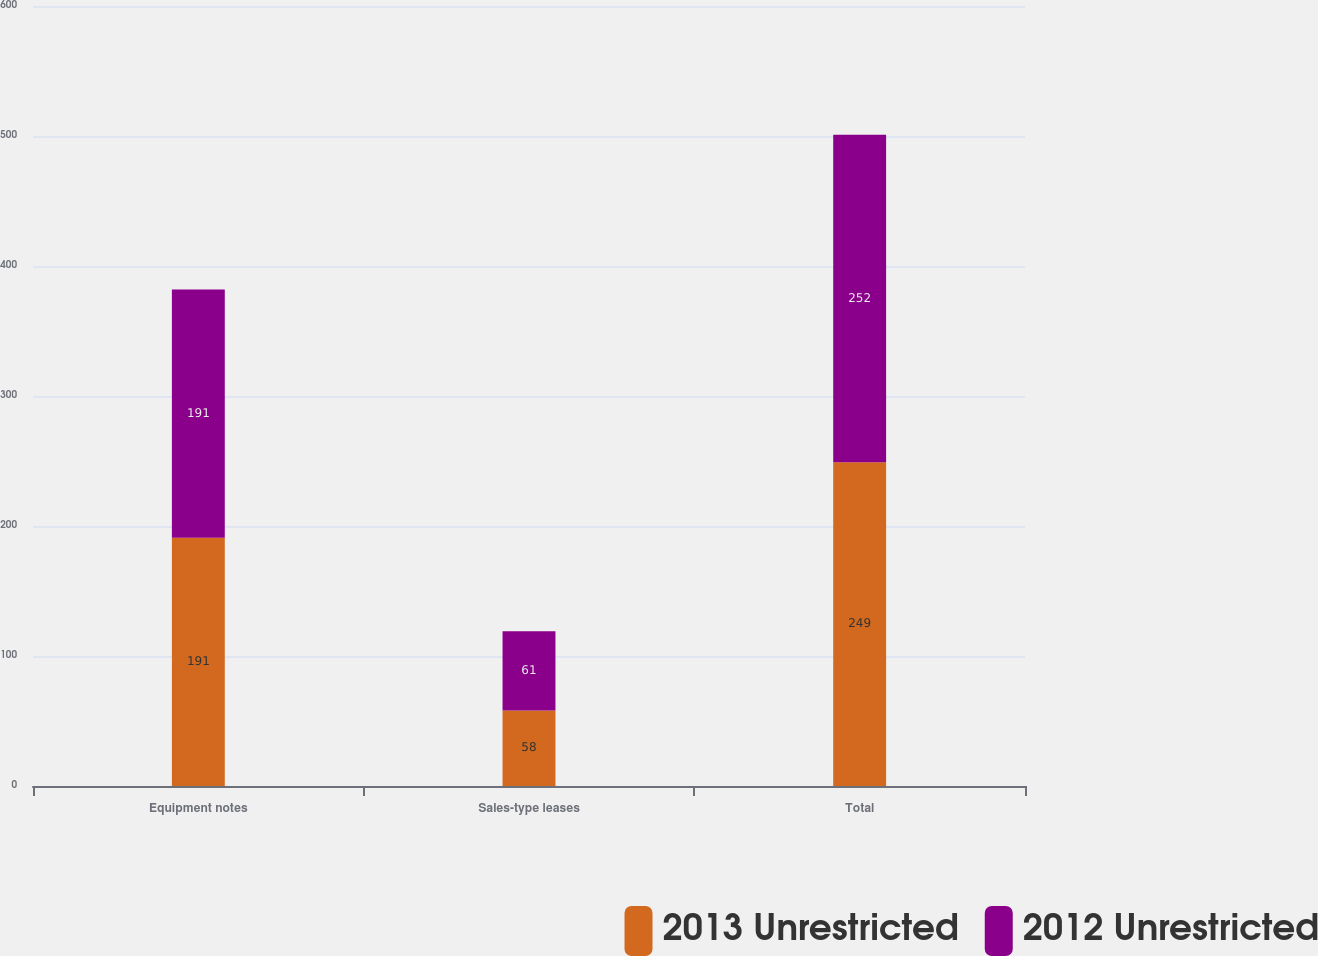<chart> <loc_0><loc_0><loc_500><loc_500><stacked_bar_chart><ecel><fcel>Equipment notes<fcel>Sales-type leases<fcel>Total<nl><fcel>2013 Unrestricted<fcel>191<fcel>58<fcel>249<nl><fcel>2012 Unrestricted<fcel>191<fcel>61<fcel>252<nl></chart> 